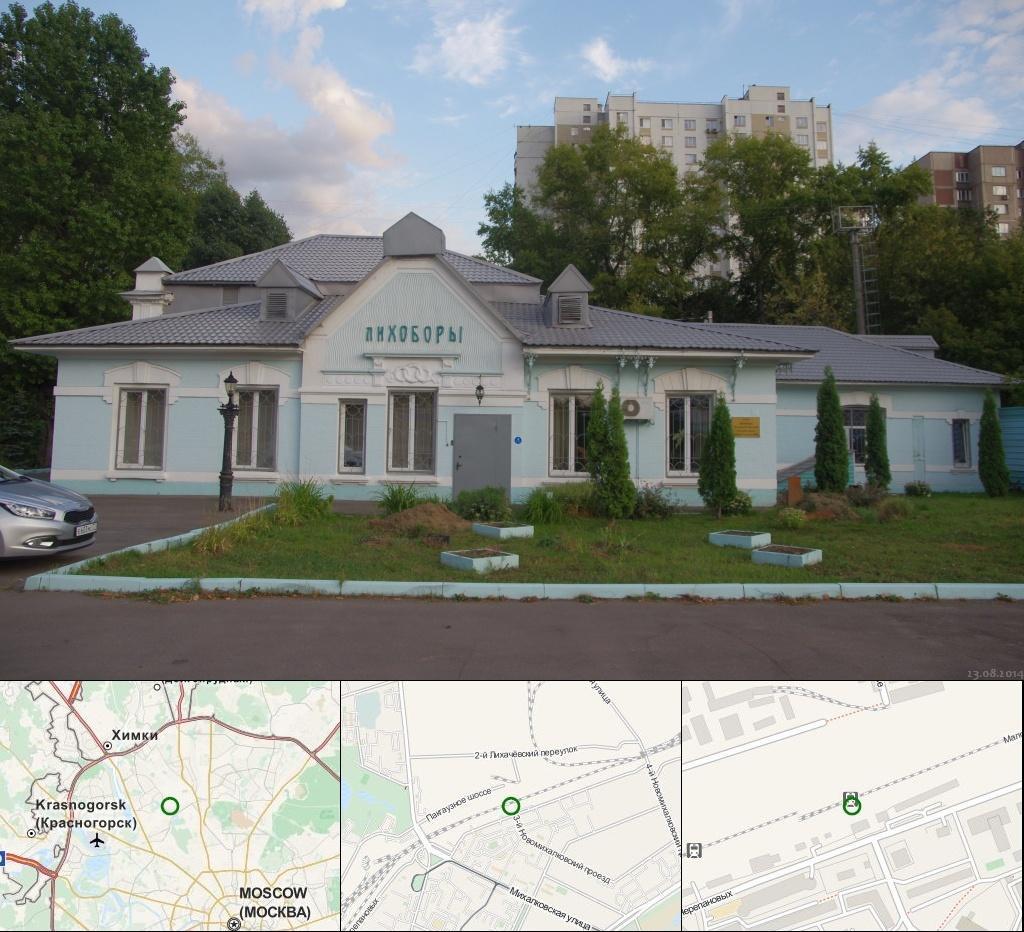In one or two sentences, can you explain what this image depicts? In this image I can see the board. In the background I can see the vehicle, trees, pole and the house with windows. I can also see many trees, buildings, clouds and the sky. 